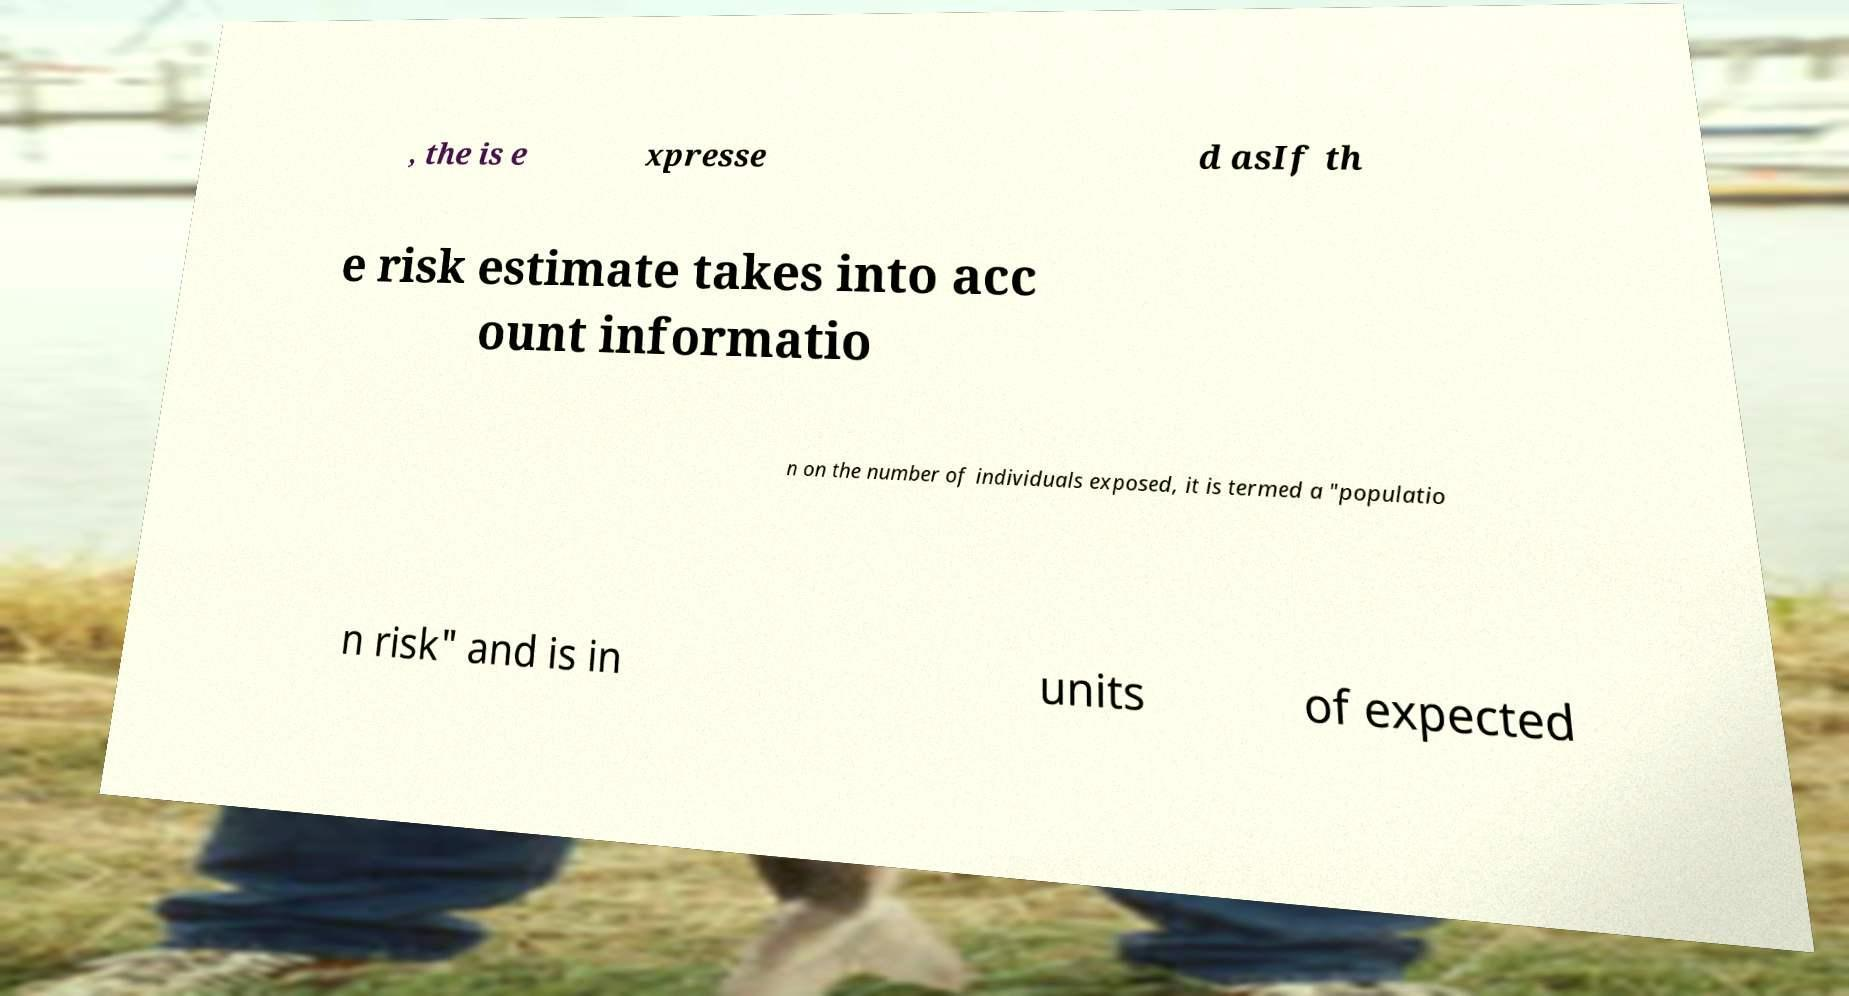Can you accurately transcribe the text from the provided image for me? , the is e xpresse d asIf th e risk estimate takes into acc ount informatio n on the number of individuals exposed, it is termed a "populatio n risk" and is in units of expected 